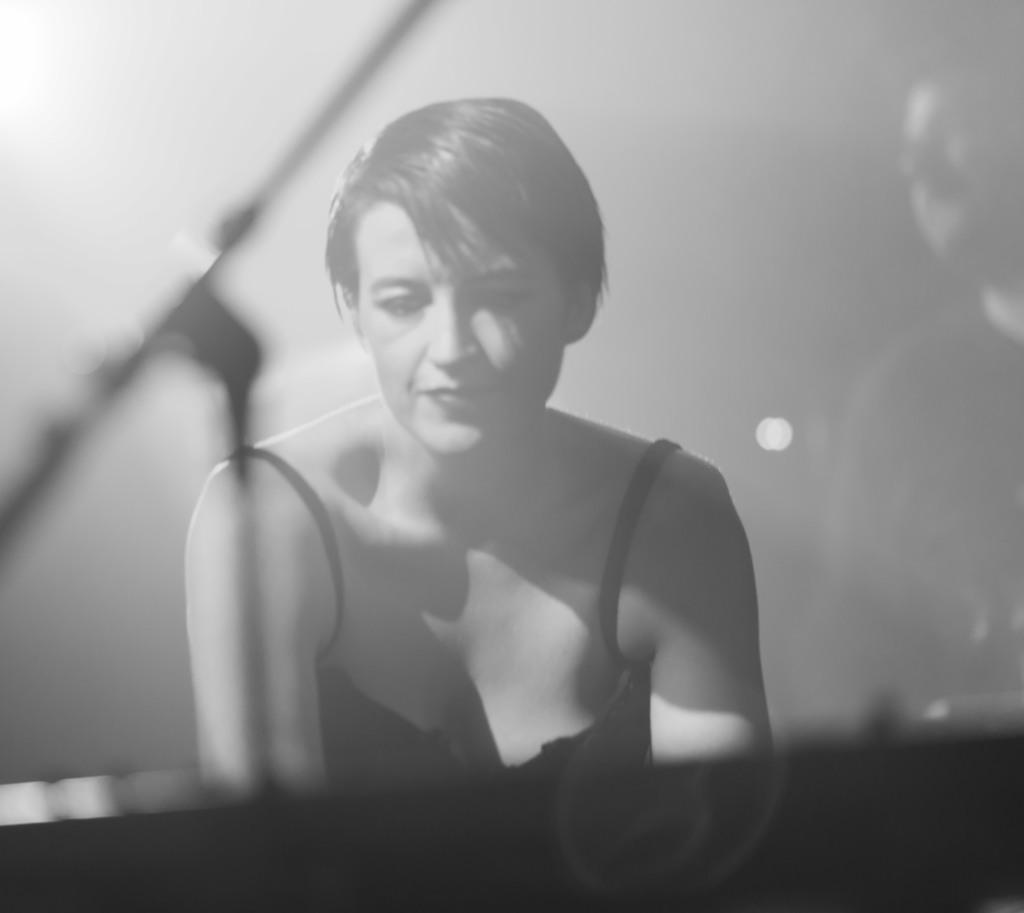What is the main subject of the image? The main subject of the image is a woman. What object is in front of the woman? There is a microphone stand in front of the woman. Can you describe the person on the right side of the image? There is a person on the right side of the image, but their specific characteristics are not mentioned in the facts. What type of underwear is the woman wearing in the image? There is no information about the woman's underwear in the image or the facts provided. How many teeth can be seen in the image? There is no mention of teeth in the image or the facts provided. 